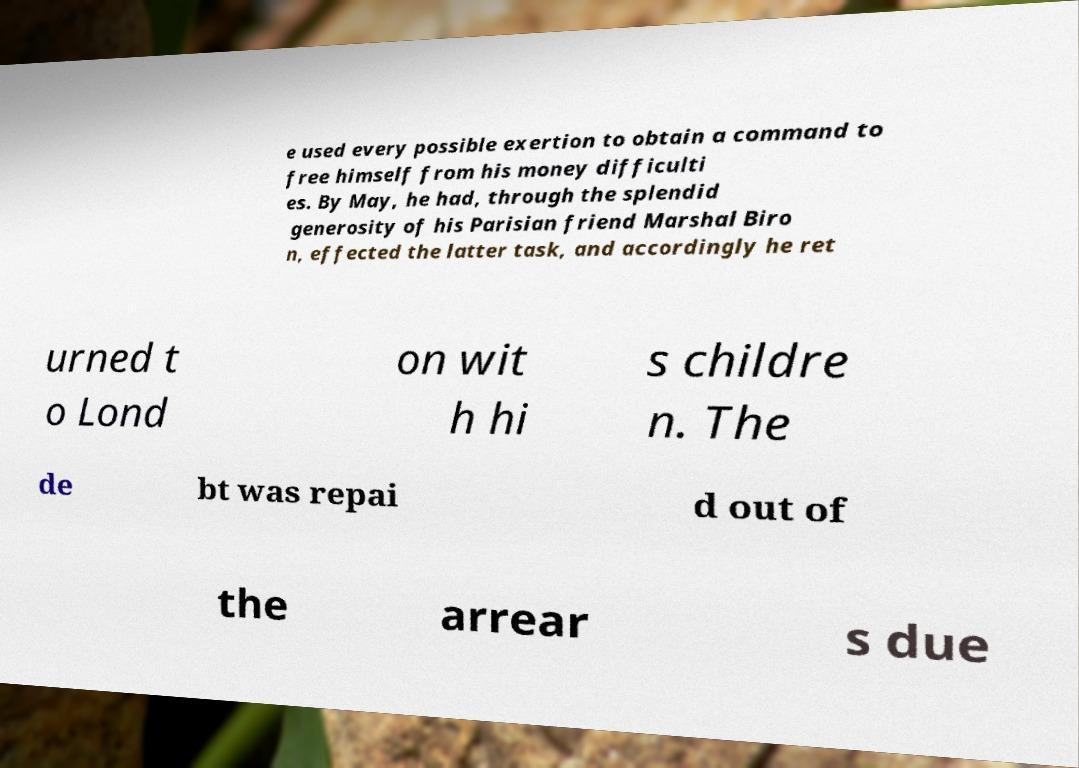I need the written content from this picture converted into text. Can you do that? e used every possible exertion to obtain a command to free himself from his money difficulti es. By May, he had, through the splendid generosity of his Parisian friend Marshal Biro n, effected the latter task, and accordingly he ret urned t o Lond on wit h hi s childre n. The de bt was repai d out of the arrear s due 